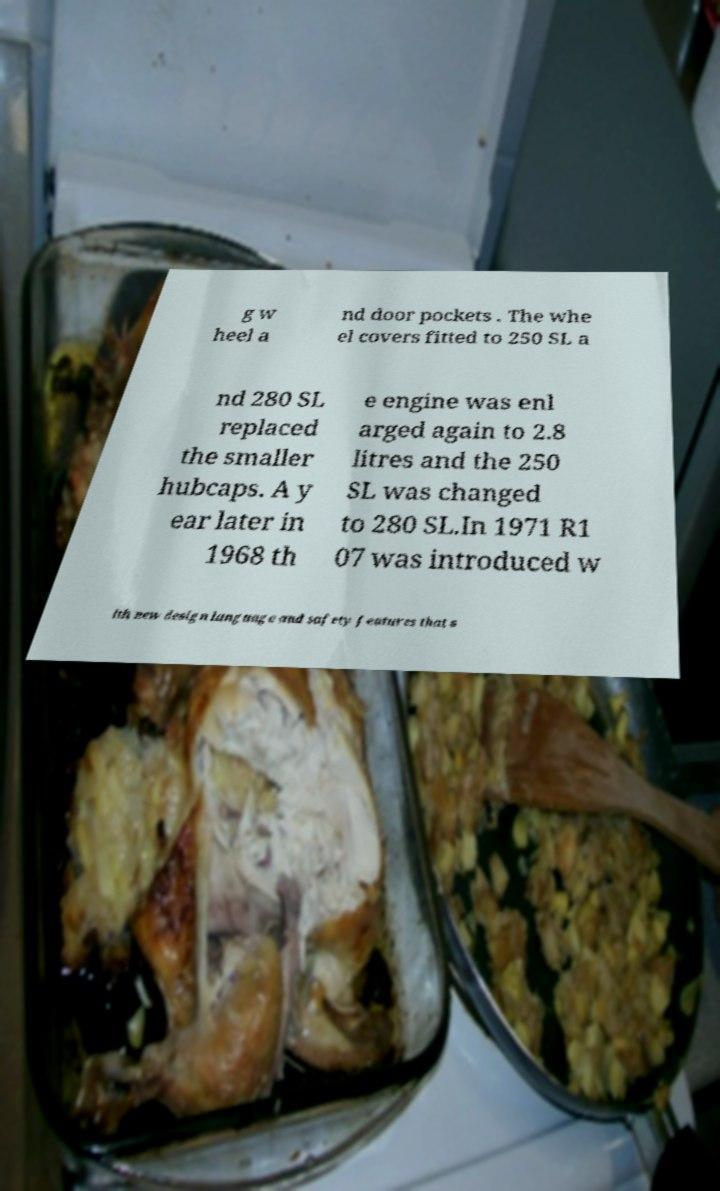Please read and relay the text visible in this image. What does it say? g w heel a nd door pockets . The whe el covers fitted to 250 SL a nd 280 SL replaced the smaller hubcaps. A y ear later in 1968 th e engine was enl arged again to 2.8 litres and the 250 SL was changed to 280 SL.In 1971 R1 07 was introduced w ith new design language and safety features that s 